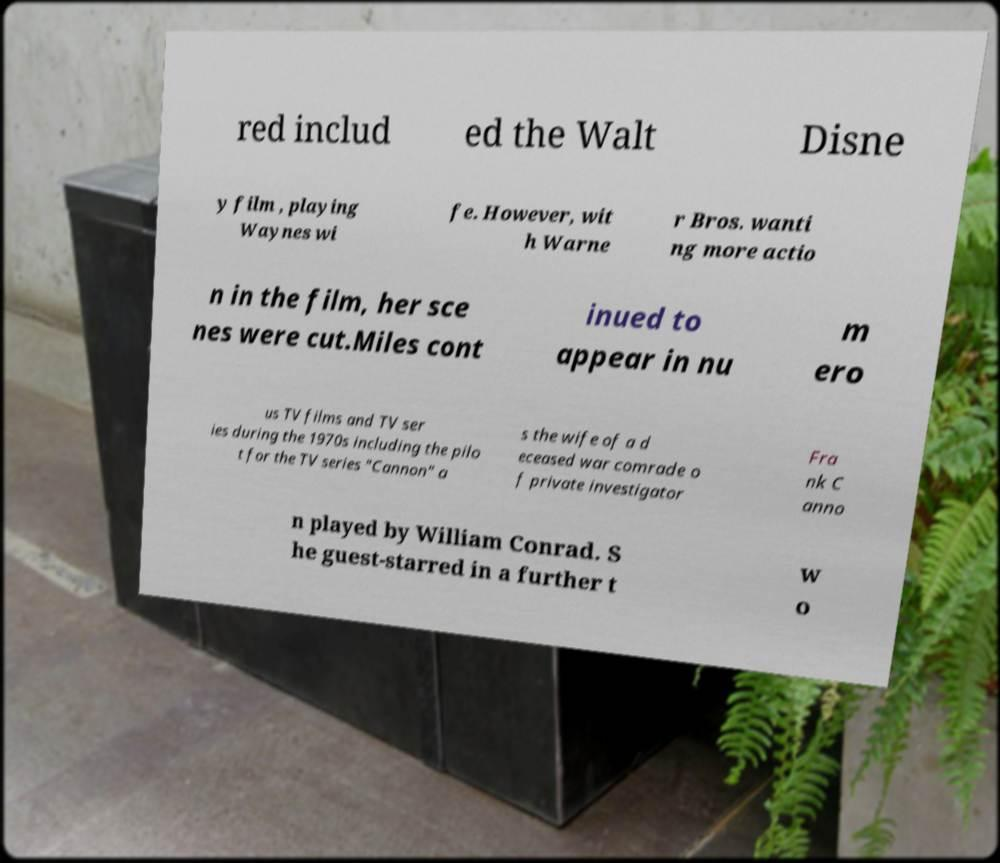I need the written content from this picture converted into text. Can you do that? red includ ed the Walt Disne y film , playing Waynes wi fe. However, wit h Warne r Bros. wanti ng more actio n in the film, her sce nes were cut.Miles cont inued to appear in nu m ero us TV films and TV ser ies during the 1970s including the pilo t for the TV series "Cannon" a s the wife of a d eceased war comrade o f private investigator Fra nk C anno n played by William Conrad. S he guest-starred in a further t w o 